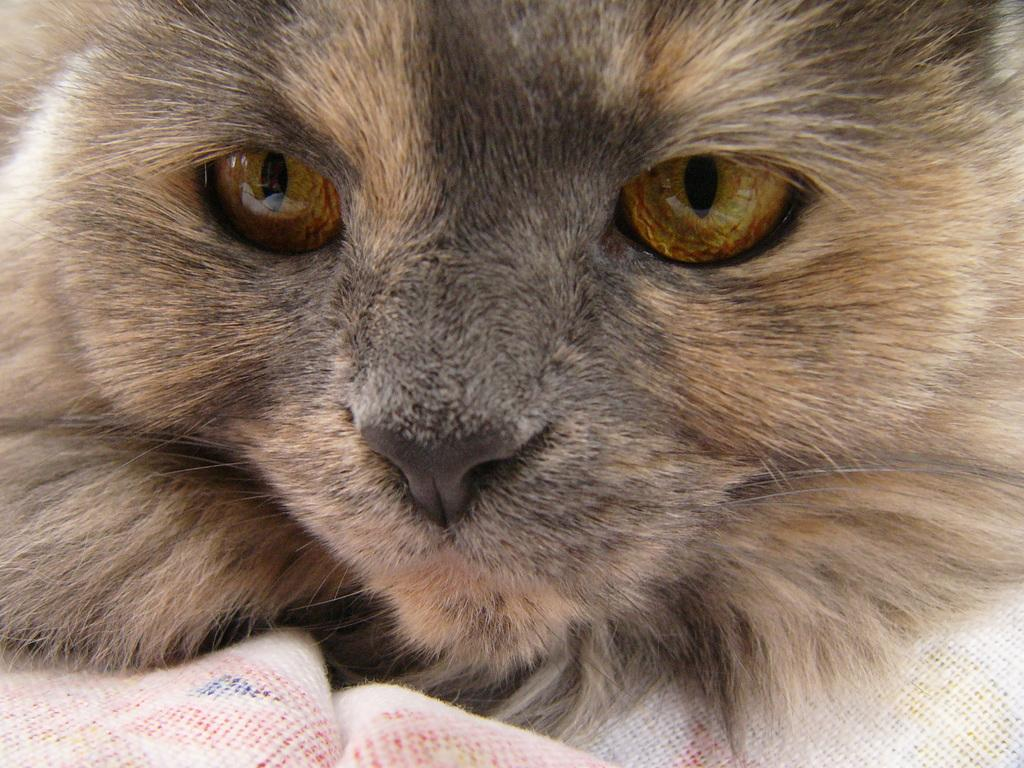What type of animal is in the image? There is a cat in the image. Can you describe the cat's fur? The cat has brown and black fur. What is the cat sitting on in the image? The cat is on a white object. What colors are the cat's eyes? The cat's eyes are gold, orange, and black in color. What color is the cat's nose? The cat's nose is black in color. What type of light is being produced by the cat in the image? There is no light being produced by the cat in the image; it is a static image of a cat. 